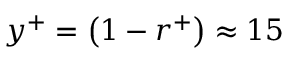Convert formula to latex. <formula><loc_0><loc_0><loc_500><loc_500>y ^ { + } = \left ( 1 - r ^ { + } \right ) \approx 1 5</formula> 